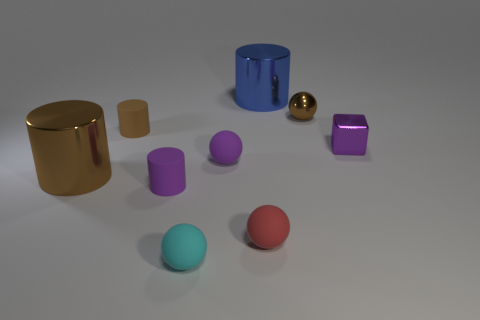Subtract 1 cylinders. How many cylinders are left? 3 Add 1 small red rubber things. How many objects exist? 10 Subtract all blocks. How many objects are left? 8 Add 5 big matte cubes. How many big matte cubes exist? 5 Subtract 1 blue cylinders. How many objects are left? 8 Subtract all big cylinders. Subtract all brown spheres. How many objects are left? 6 Add 2 brown rubber cylinders. How many brown rubber cylinders are left? 3 